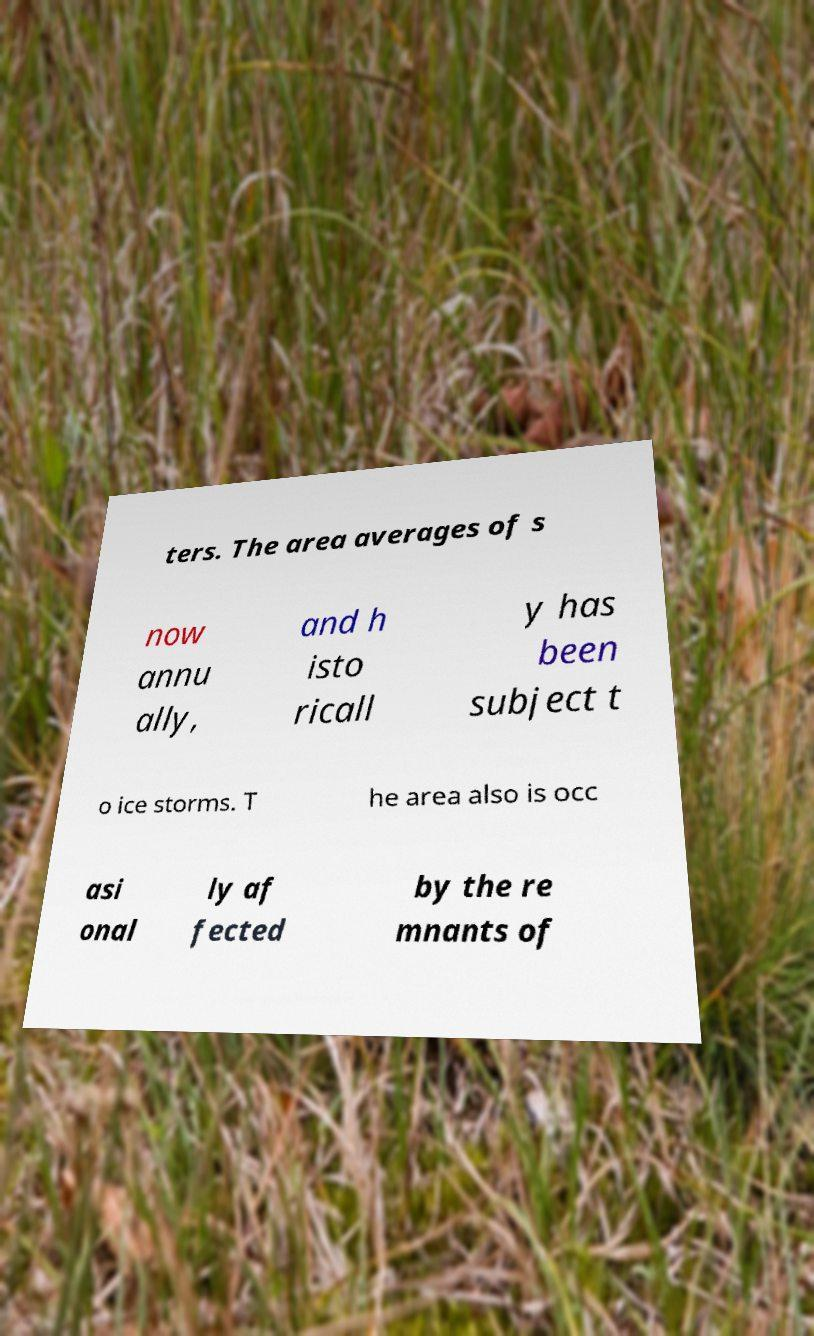Please identify and transcribe the text found in this image. ters. The area averages of s now annu ally, and h isto ricall y has been subject t o ice storms. T he area also is occ asi onal ly af fected by the re mnants of 